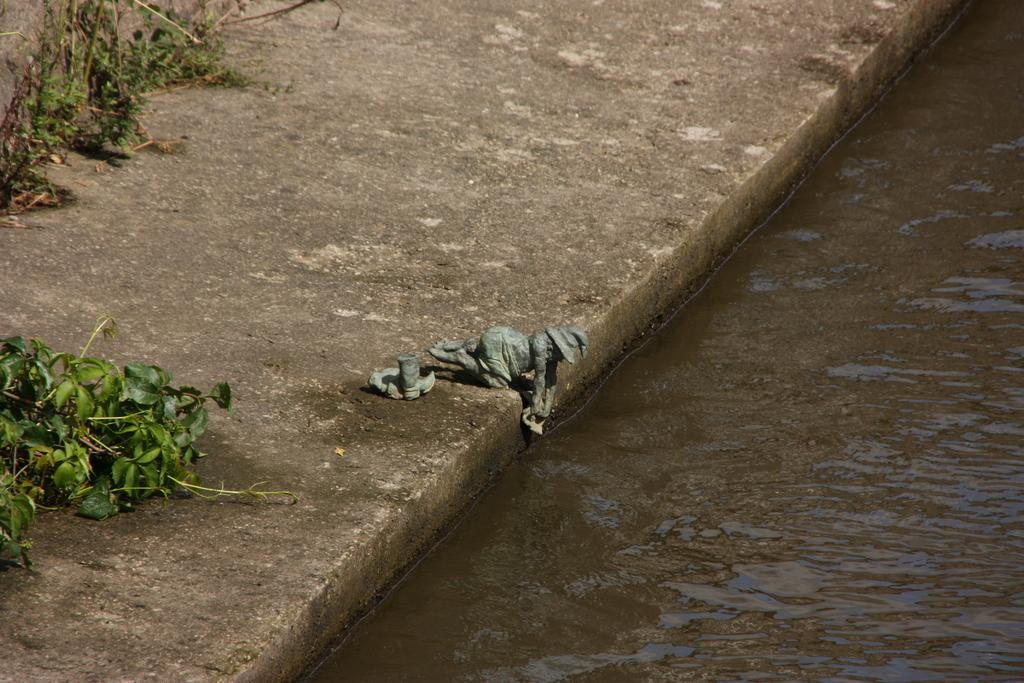What can be found on the floor in the image? There are statues on the floor in the image. What type of vegetation is present in the image? Creepers and plants are visible in the image. Is there any liquid element in the image? Yes, there is water in the image. How many bananas are hanging from the creepers in the image? There are no bananas present in the image; only creepers and plants are visible. What type of credit card is being used in the image? There is no credit card or any financial transaction depicted in the image. 